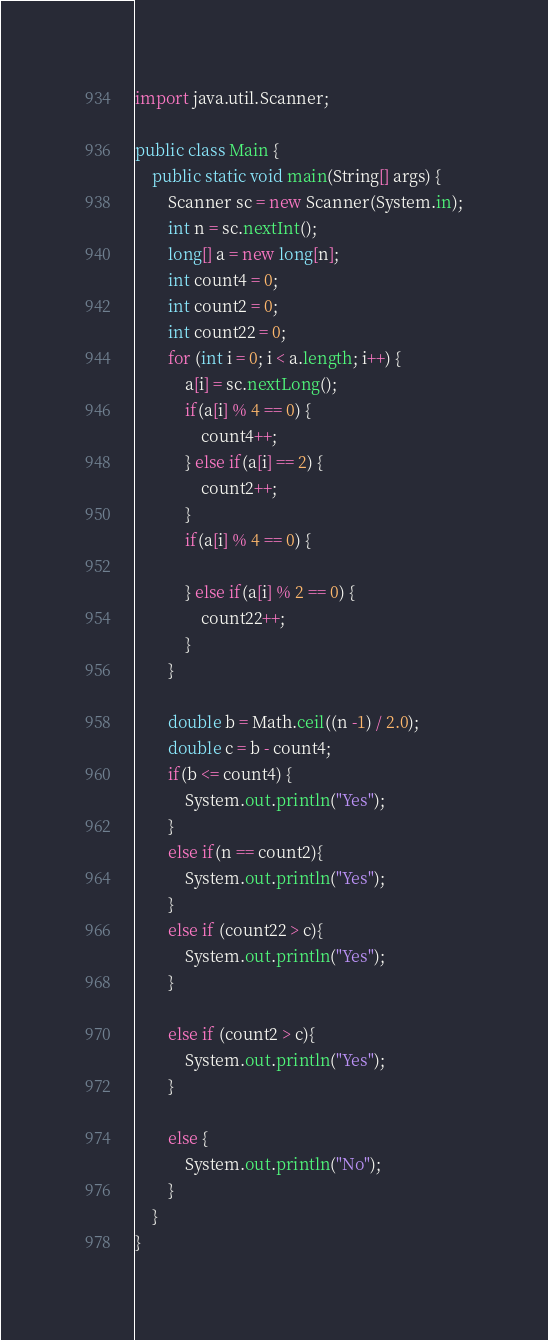Convert code to text. <code><loc_0><loc_0><loc_500><loc_500><_Java_>import java.util.Scanner;

public class Main {
    public static void main(String[] args) {
        Scanner sc = new Scanner(System.in);
        int n = sc.nextInt();
        long[] a = new long[n];
        int count4 = 0;
        int count2 = 0;
        int count22 = 0;
        for (int i = 0; i < a.length; i++) {
            a[i] = sc.nextLong();
            if(a[i] % 4 == 0) {
                count4++;
            } else if(a[i] == 2) {
                count2++;
            }
            if(a[i] % 4 == 0) {

            } else if(a[i] % 2 == 0) {
                count22++;
            }
        }

        double b = Math.ceil((n -1) / 2.0);
        double c = b - count4;
        if(b <= count4) {
            System.out.println("Yes");
        }
        else if(n == count2){
            System.out.println("Yes");
        }
        else if (count22 > c){
            System.out.println("Yes");
        }

        else if (count2 > c){
            System.out.println("Yes");
        }

        else {
            System.out.println("No");
        }
    }
}</code> 